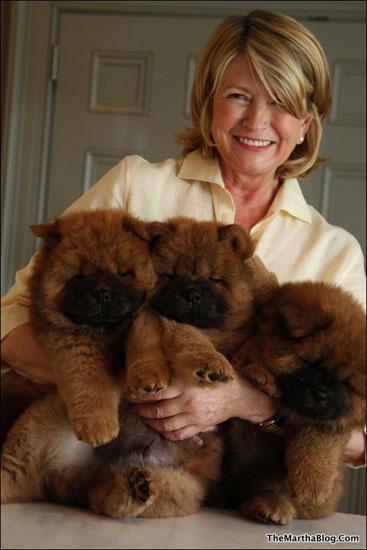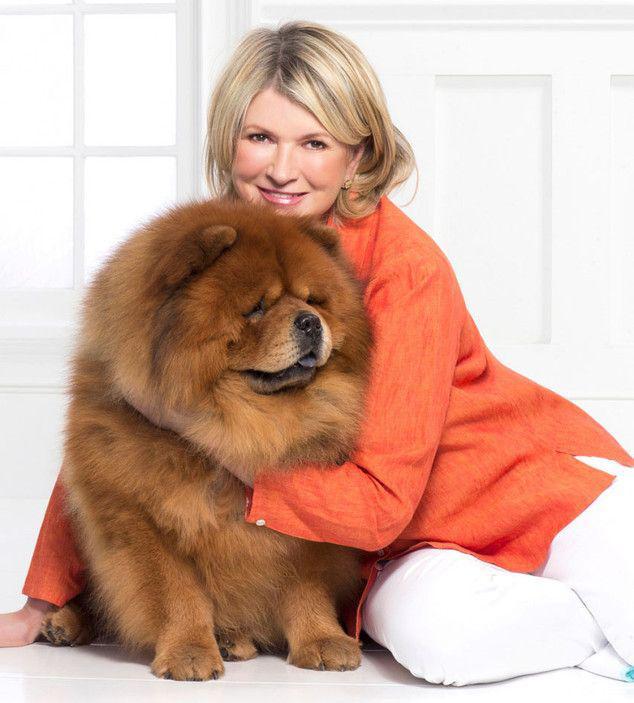The first image is the image on the left, the second image is the image on the right. Considering the images on both sides, is "A person is holding at least two fluffy Chow Chow puppies in the image on the left." valid? Answer yes or no. Yes. The first image is the image on the left, the second image is the image on the right. Analyze the images presented: Is the assertion "The left image features a person holding at least two chow puppies in front of their chest." valid? Answer yes or no. Yes. 